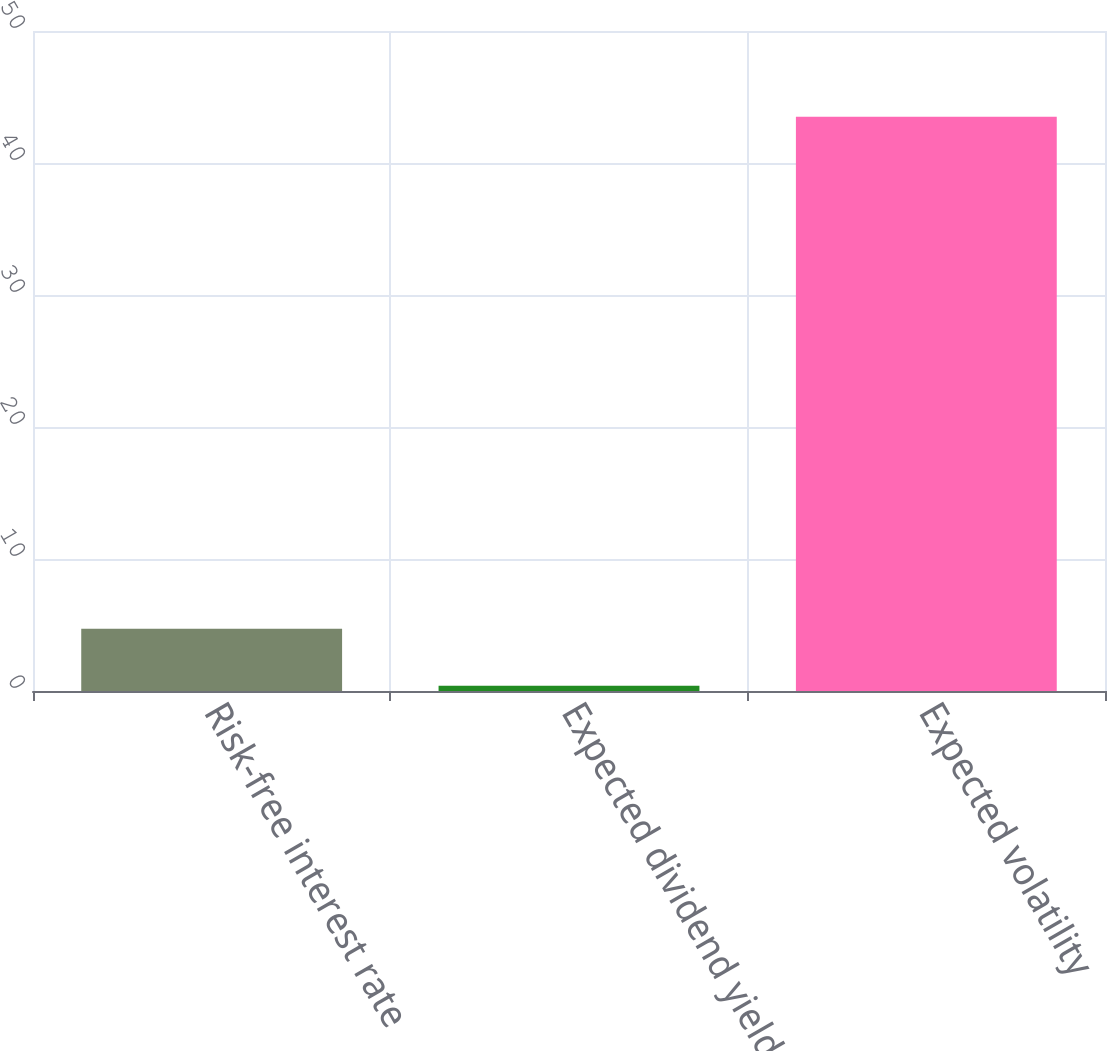Convert chart to OTSL. <chart><loc_0><loc_0><loc_500><loc_500><bar_chart><fcel>Risk-free interest rate<fcel>Expected dividend yield<fcel>Expected volatility<nl><fcel>4.71<fcel>0.4<fcel>43.5<nl></chart> 